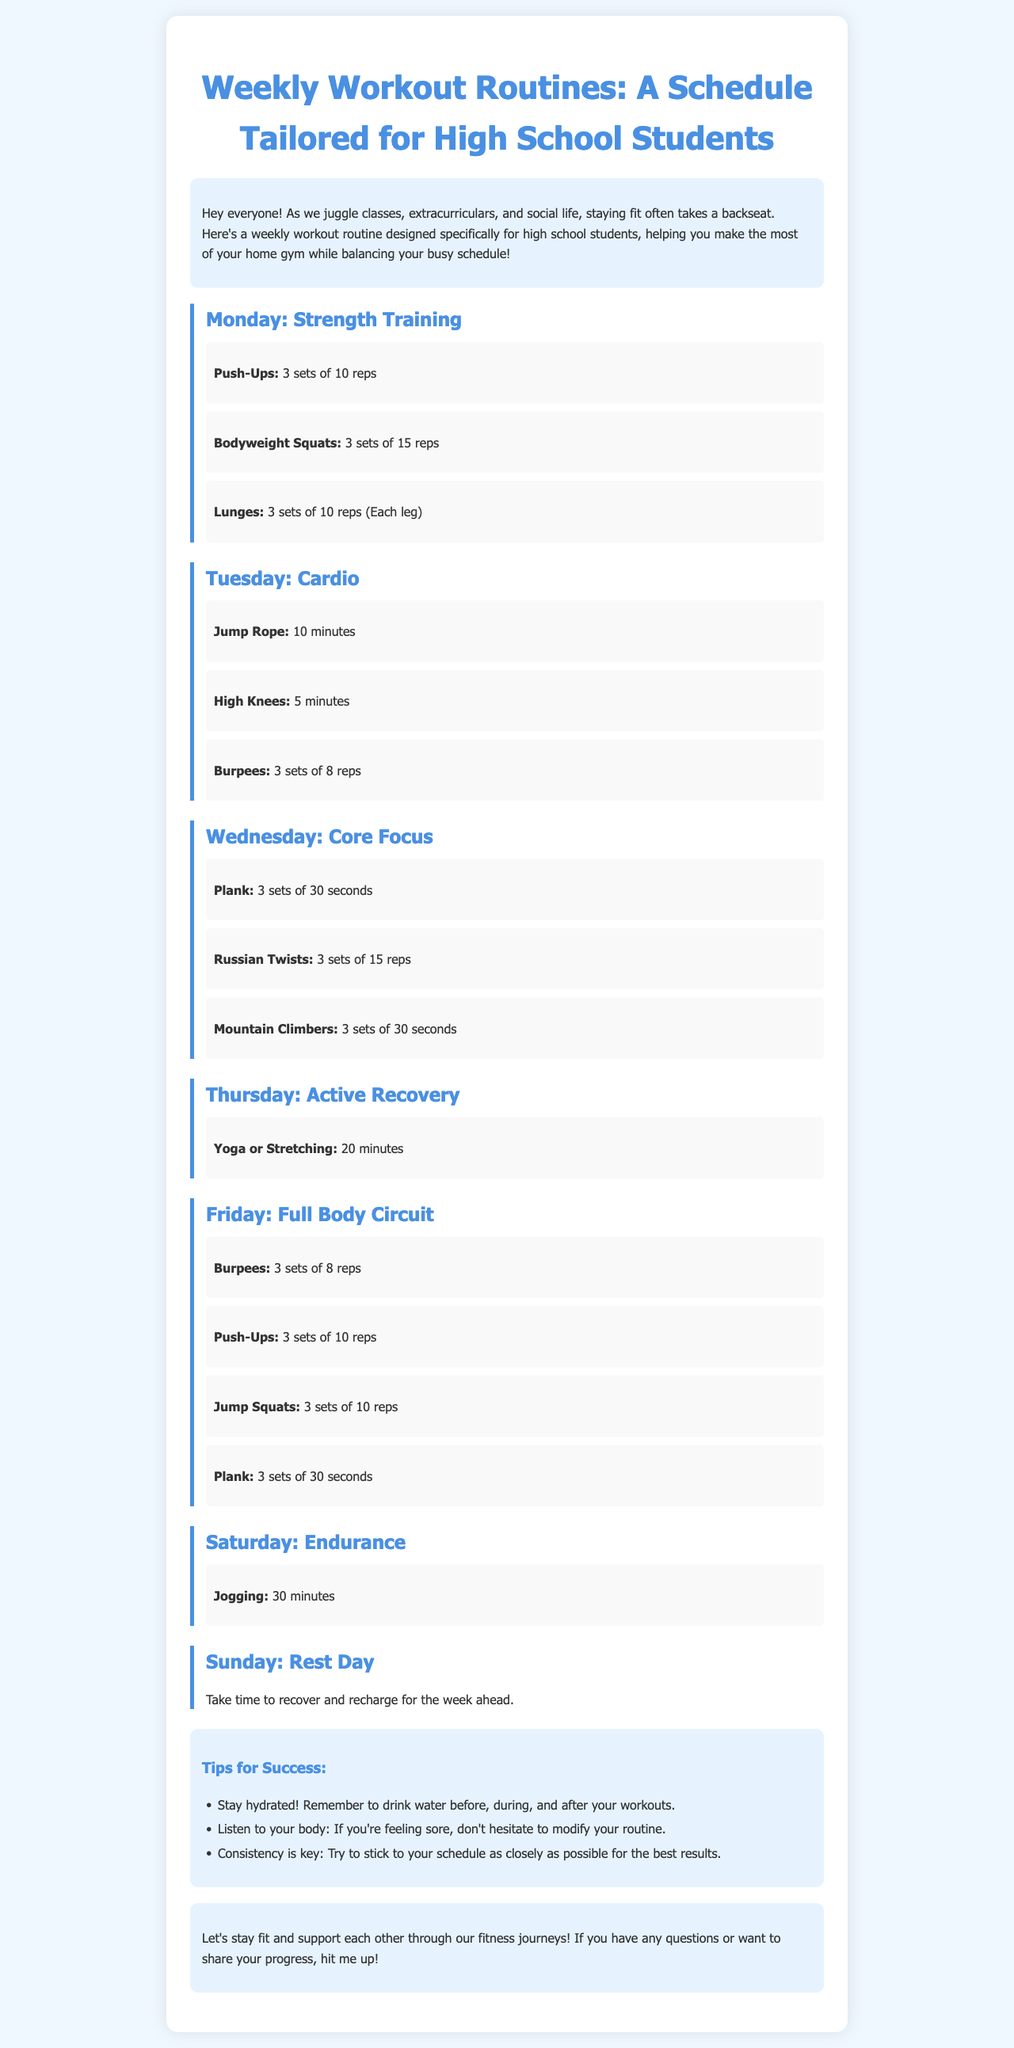What is the main focus of the newsletter? The main focus is on providing weekly workout routines tailored for high school students.
Answer: weekly workout routines How many strength training exercises are listed for Monday? The number of exercises listed for Monday under strength training includes Push-Ups, Bodyweight Squats, and Lunges.
Answer: 3 What type of workout is suggested for Tuesday? The workout suggested for Tuesday emphasizes getting the heart rate up with high-energy movements.
Answer: Cardio How long should the yoga or stretching session last on Thursday? The document specifies a duration for the yoga or stretching session on Thursday, which is a relaxing recovery activity.
Answer: 20 minutes What is the designated activity for Sunday? Sunday is meant to provide a day of rest as indicated in the routine's schedule to allow recovery.
Answer: Rest Day Which exercise is repeated on both Tuesday and Friday? The exercise that appears on both Tuesday's Cardio day and Friday's Full Body Circuit is noted in the circuit tasks listed.
Answer: Burpees What is one of the tips mentioned for success in the workouts? One of the success tips highlights the importance of hydration before and throughout the workout routine.
Answer: Stay hydrated How many sets and reps are recommended for Push-Ups on Monday? The specific recommendation for Push-Ups on Monday includes details about the number of sets and repetitions expected from students.
Answer: 3 sets of 10 reps 